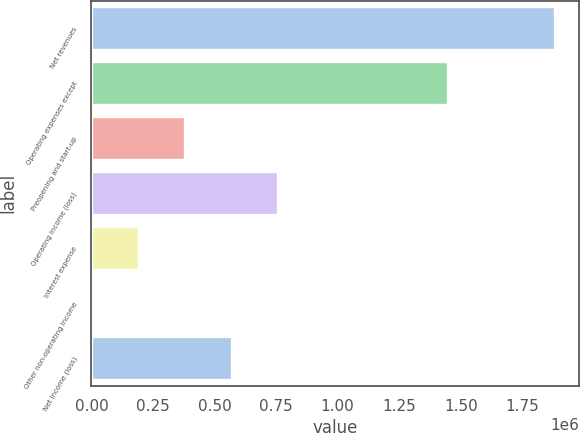Convert chart. <chart><loc_0><loc_0><loc_500><loc_500><bar_chart><fcel>Net revenues<fcel>Operating expenses except<fcel>Preopening and start-up<fcel>Operating income (loss)<fcel>Interest expense<fcel>Other non-operating income<fcel>Net income (loss)<nl><fcel>1.8845e+06<fcel>1.44775e+06<fcel>381056<fcel>756918<fcel>193125<fcel>5194<fcel>568987<nl></chart> 